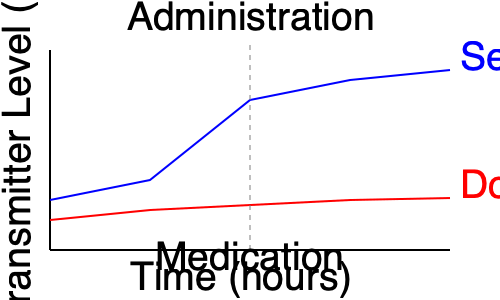Analyze the graph showing neurotransmitter levels before and after medication administration. Which neurotransmitter shows a more pronounced change, and what might this suggest about the medication's primary mechanism of action? To answer this question, we need to examine the changes in both neurotransmitter levels (serotonin and dopamine) before and after medication administration:

1. Identify the point of medication administration:
   - The vertical dashed line at the center of the graph indicates the time of medication administration.

2. Analyze serotonin levels (blue line):
   - Before medication: Relatively stable with a slight downward trend.
   - After medication: Sharp increase, followed by a continued upward trend.
   - Overall change: Significant increase from ~180 ng/mL to ~70 ng/mL.

3. Analyze dopamine levels (red line):
   - Before medication: Relatively stable with a very slight downward trend.
   - After medication: Minimal change, with a very slight continued downward trend.
   - Overall change: Minimal, from ~210 ng/mL to ~198 ng/mL.

4. Compare the changes:
   - Serotonin shows a much more pronounced change compared to dopamine.
   - The increase in serotonin levels is substantial, while dopamine levels remain relatively constant.

5. Interpret the results:
   - The significant increase in serotonin levels suggests that the medication's primary mechanism of action is likely related to serotonin regulation.
   - This could indicate that the medication is a selective serotonin reuptake inhibitor (SSRI) or has a similar mechanism that primarily affects serotonin levels.

6. Consider the implications:
   - The medication appears to have a targeted effect on serotonin, with minimal impact on dopamine levels.
   - This specificity could be beneficial in treating conditions associated with serotonin imbalance, such as depression or anxiety, while potentially minimizing side effects related to dopamine regulation.
Answer: Serotonin shows a more pronounced change, suggesting the medication's primary mechanism of action involves serotonin regulation, possibly as an SSRI. 